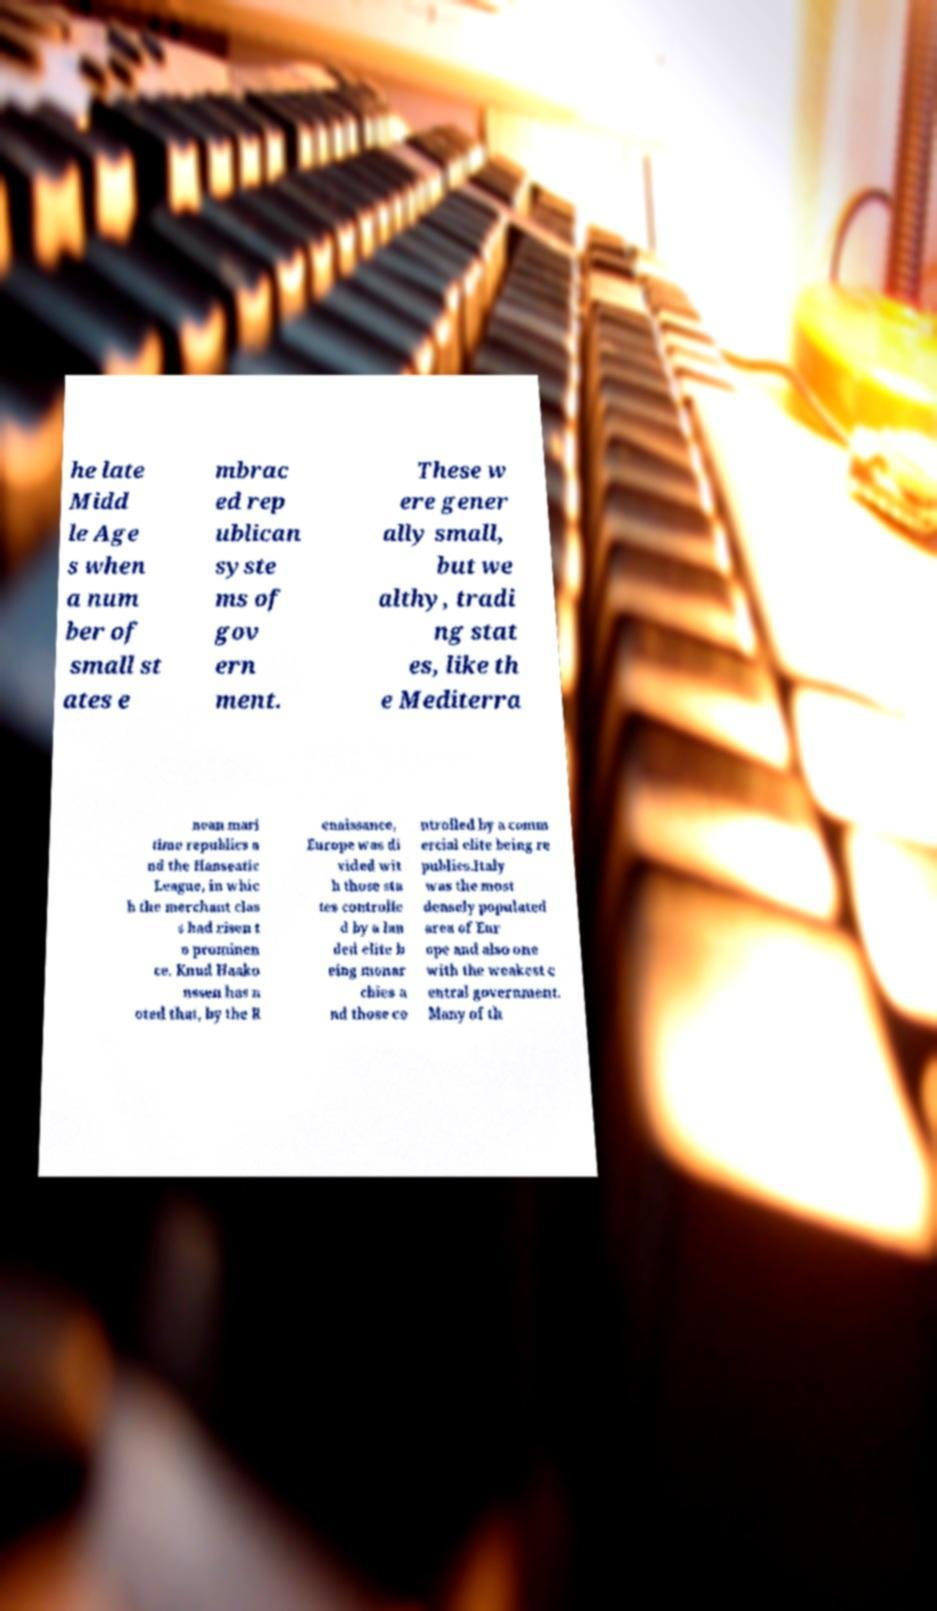Could you assist in decoding the text presented in this image and type it out clearly? he late Midd le Age s when a num ber of small st ates e mbrac ed rep ublican syste ms of gov ern ment. These w ere gener ally small, but we althy, tradi ng stat es, like th e Mediterra nean mari time republics a nd the Hanseatic League, in whic h the merchant clas s had risen t o prominen ce. Knud Haako nssen has n oted that, by the R enaissance, Europe was di vided wit h those sta tes controlle d by a lan ded elite b eing monar chies a nd those co ntrolled by a comm ercial elite being re publics.Italy was the most densely populated area of Eur ope and also one with the weakest c entral government. Many of th 